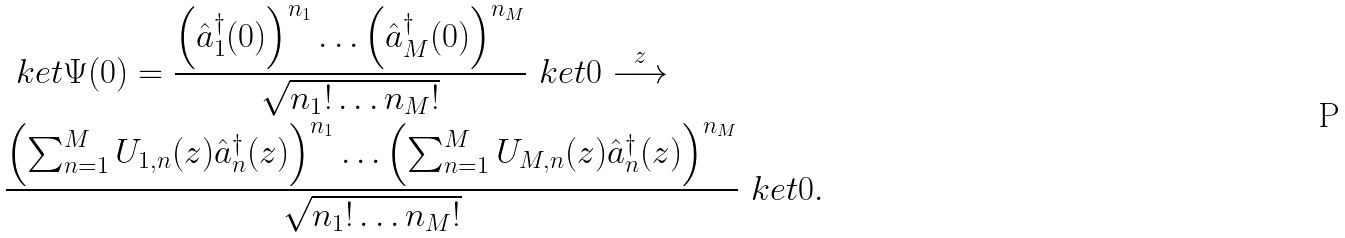Convert formula to latex. <formula><loc_0><loc_0><loc_500><loc_500>& \ k e t { \Psi ( 0 ) } = \frac { \left ( \hat { a } ^ { \dagger } _ { 1 } ( 0 ) \right ) ^ { n _ { 1 } } \dots \left ( \hat { a } ^ { \dagger } _ { M } ( 0 ) \right ) ^ { n _ { M } } } { \sqrt { n _ { 1 } ! \dots n _ { M } ! } } \ k e t { 0 } \overset { z } { \longrightarrow } \\ & \frac { \left ( \sum _ { n = 1 } ^ { M } U _ { 1 , n } ( z ) \hat { a } ^ { \dagger } _ { n } ( z ) \right ) ^ { n _ { 1 } } \dots \left ( \sum _ { n = 1 } ^ { M } U _ { M , n } ( z ) \hat { a } ^ { \dagger } _ { n } ( z ) \right ) ^ { n _ { M } } } { \sqrt { n _ { 1 } ! \dots n _ { M } ! } } \ k e t { 0 } .</formula> 